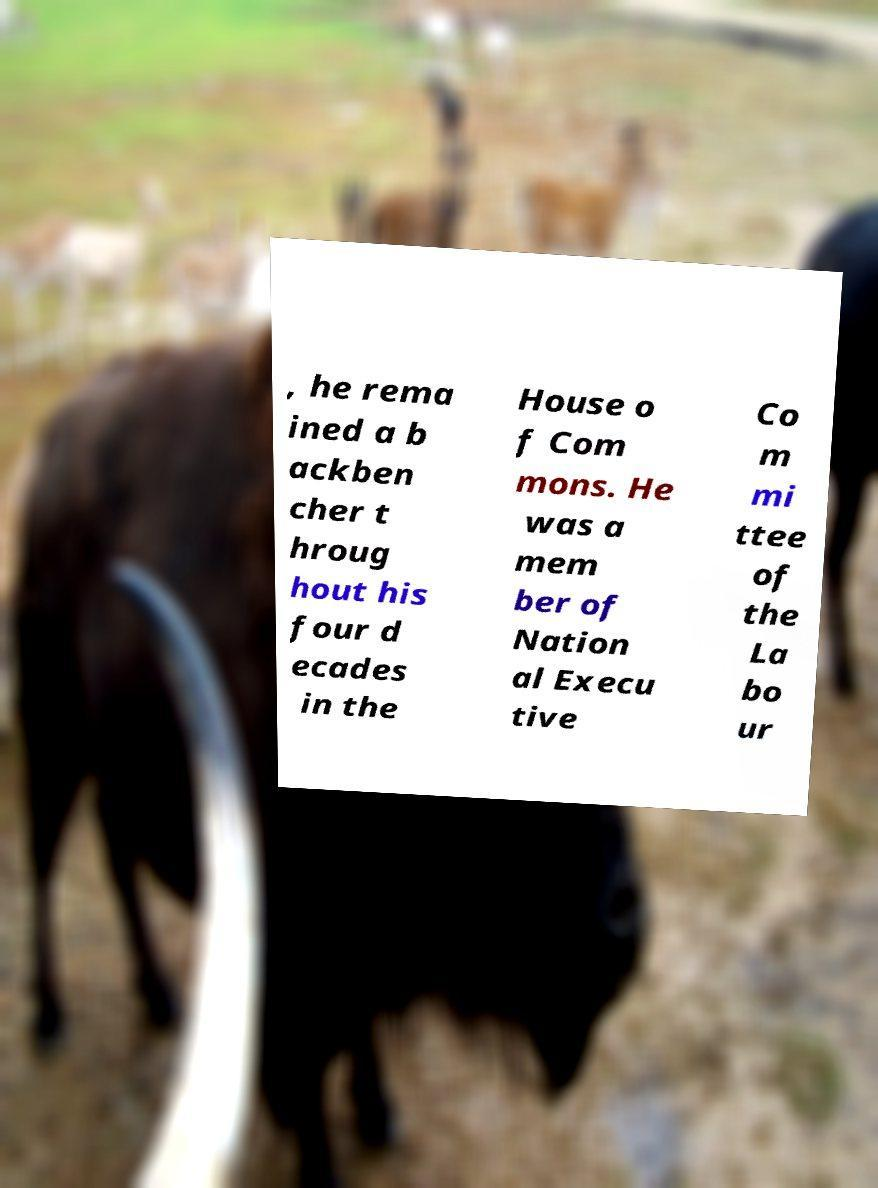Could you extract and type out the text from this image? , he rema ined a b ackben cher t hroug hout his four d ecades in the House o f Com mons. He was a mem ber of Nation al Execu tive Co m mi ttee of the La bo ur 